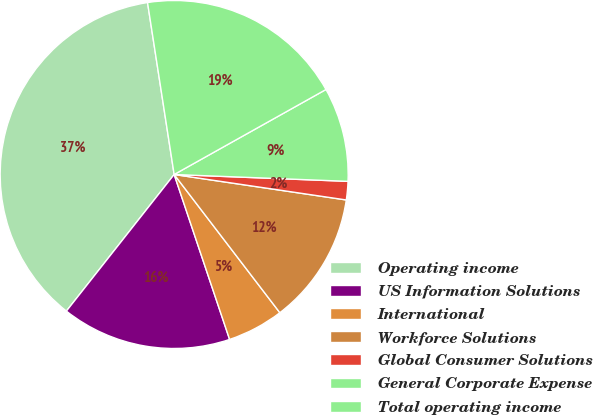Convert chart to OTSL. <chart><loc_0><loc_0><loc_500><loc_500><pie_chart><fcel>Operating income<fcel>US Information Solutions<fcel>International<fcel>Workforce Solutions<fcel>Global Consumer Solutions<fcel>General Corporate Expense<fcel>Total operating income<nl><fcel>36.92%<fcel>15.79%<fcel>5.23%<fcel>12.27%<fcel>1.71%<fcel>8.75%<fcel>19.32%<nl></chart> 